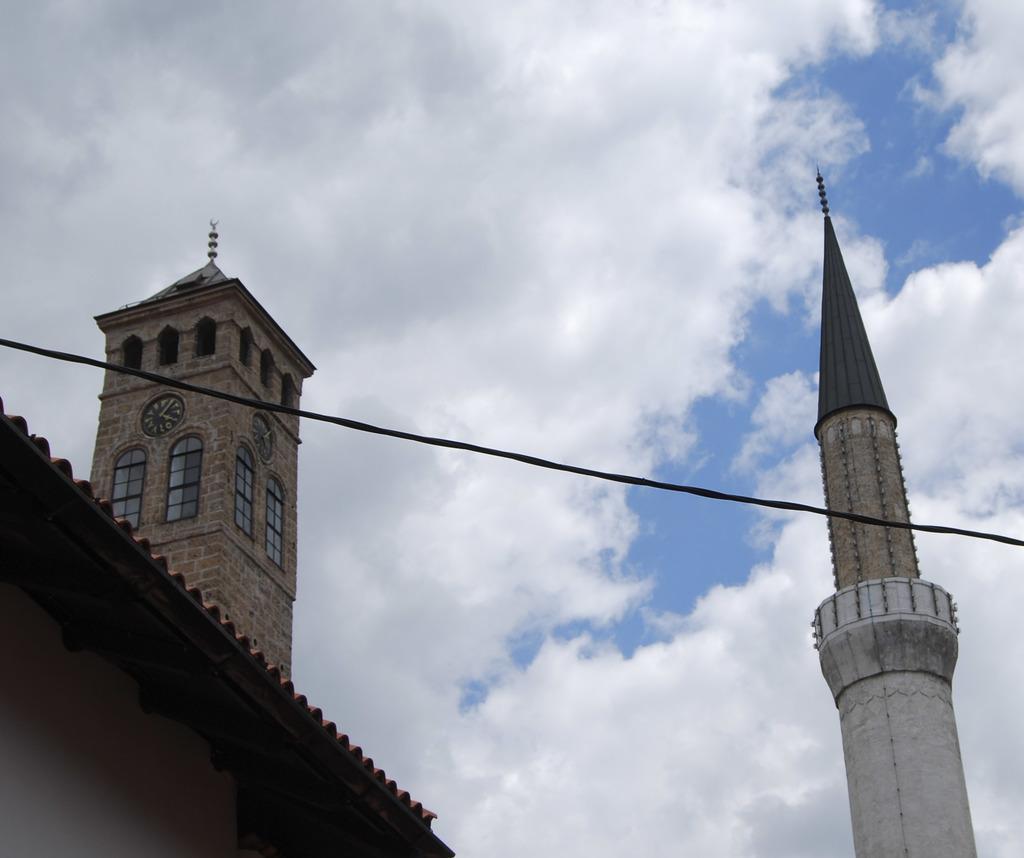Can you describe this image briefly? In the center of the image there is a rope. There is a building with a clock tower. At the top of the image there are clouds. 